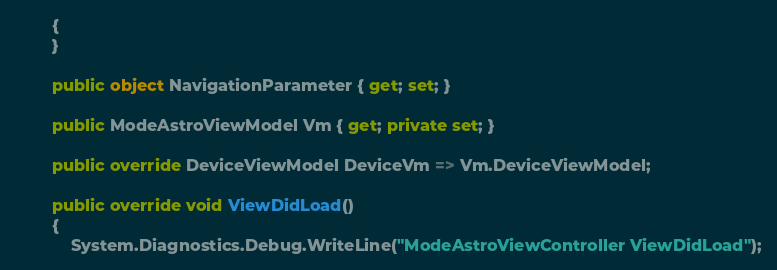<code> <loc_0><loc_0><loc_500><loc_500><_C#_>        {
        }

        public object NavigationParameter { get; set; }

        public ModeAstroViewModel Vm { get; private set; }

        public override DeviceViewModel DeviceVm => Vm.DeviceViewModel;

        public override void ViewDidLoad()
        {
            System.Diagnostics.Debug.WriteLine("ModeAstroViewController ViewDidLoad");
</code> 